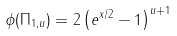Convert formula to latex. <formula><loc_0><loc_0><loc_500><loc_500>\phi ( \Pi _ { 1 , u } ) = 2 \left ( e ^ { x / 2 } - 1 \right ) ^ { u + 1 }</formula> 